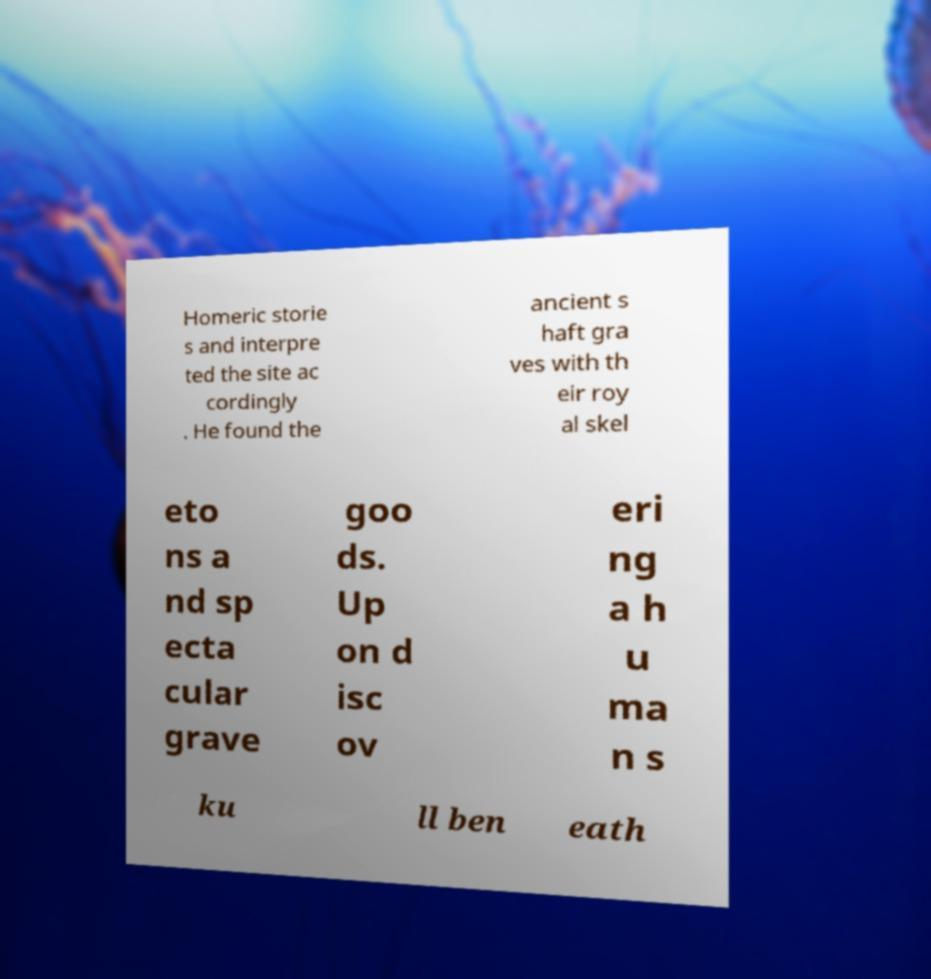Please read and relay the text visible in this image. What does it say? Homeric storie s and interpre ted the site ac cordingly . He found the ancient s haft gra ves with th eir roy al skel eto ns a nd sp ecta cular grave goo ds. Up on d isc ov eri ng a h u ma n s ku ll ben eath 